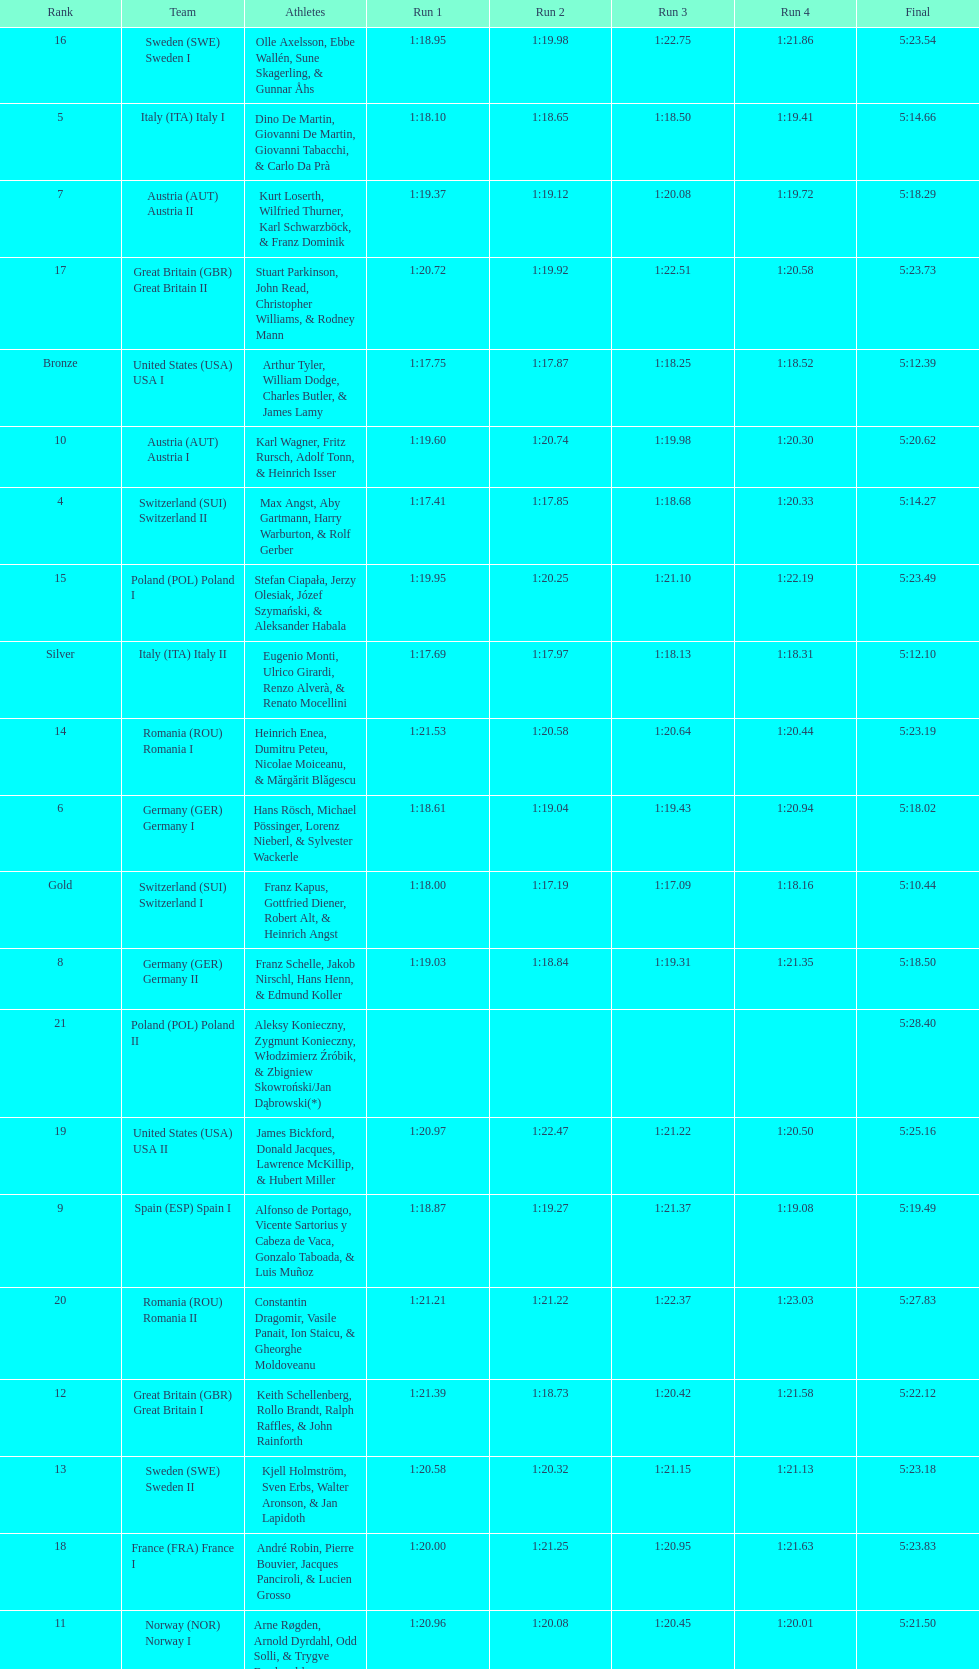What team comes after italy (ita) italy i? Germany I. 